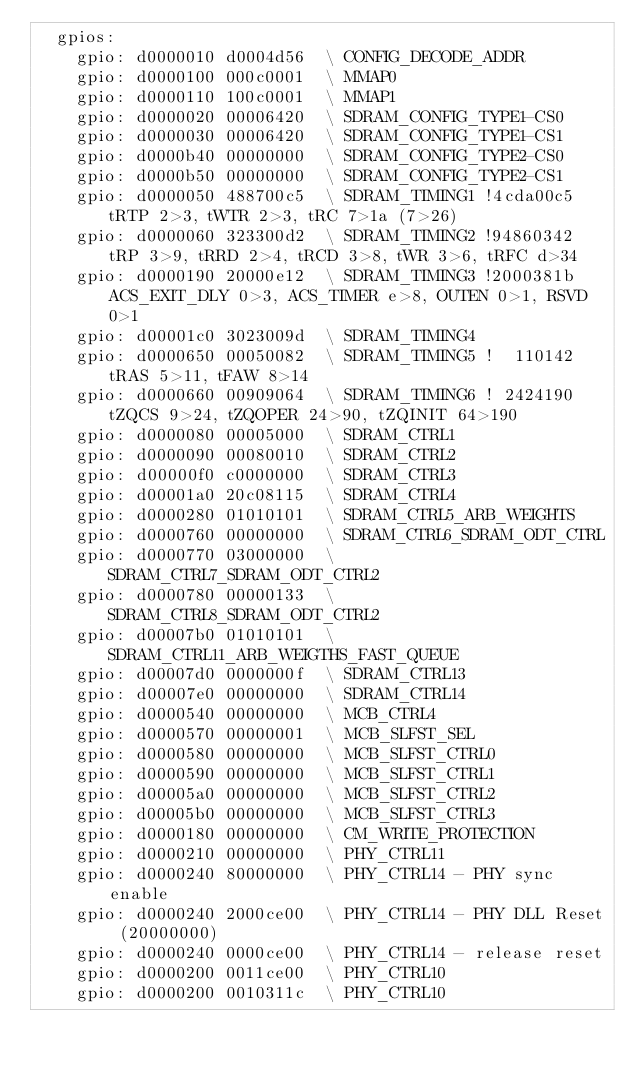Convert code to text. <code><loc_0><loc_0><loc_500><loc_500><_Forth_>  gpios:
    gpio: d0000010 d0004d56  \ CONFIG_DECODE_ADDR
    gpio: d0000100 000c0001  \ MMAP0
    gpio: d0000110 100c0001  \ MMAP1
    gpio: d0000020 00006420  \ SDRAM_CONFIG_TYPE1-CS0
    gpio: d0000030 00006420  \ SDRAM_CONFIG_TYPE1-CS1
    gpio: d0000b40 00000000  \ SDRAM_CONFIG_TYPE2-CS0
    gpio: d0000b50 00000000  \ SDRAM_CONFIG_TYPE2-CS1
    gpio: d0000050 488700c5  \ SDRAM_TIMING1 !4cda00c5 tRTP 2>3, tWTR 2>3, tRC 7>1a (7>26)
    gpio: d0000060 323300d2  \ SDRAM_TIMING2 !94860342 tRP 3>9, tRRD 2>4, tRCD 3>8, tWR 3>6, tRFC d>34
    gpio: d0000190 20000e12  \ SDRAM_TIMING3 !2000381b ACS_EXIT_DLY 0>3, ACS_TIMER e>8, OUTEN 0>1, RSVD 0>1
    gpio: d00001c0 3023009d  \ SDRAM_TIMING4
    gpio: d0000650 00050082  \ SDRAM_TIMING5 !  110142 tRAS 5>11, tFAW 8>14
    gpio: d0000660 00909064  \ SDRAM_TIMING6 ! 2424190 tZQCS 9>24, tZQOPER 24>90, tZQINIT 64>190
    gpio: d0000080 00005000  \ SDRAM_CTRL1
    gpio: d0000090 00080010  \ SDRAM_CTRL2
    gpio: d00000f0 c0000000  \ SDRAM_CTRL3
    gpio: d00001a0 20c08115  \ SDRAM_CTRL4
    gpio: d0000280 01010101  \ SDRAM_CTRL5_ARB_WEIGHTS
    gpio: d0000760 00000000  \ SDRAM_CTRL6_SDRAM_ODT_CTRL
    gpio: d0000770 03000000  \ SDRAM_CTRL7_SDRAM_ODT_CTRL2
    gpio: d0000780 00000133  \ SDRAM_CTRL8_SDRAM_ODT_CTRL2
    gpio: d00007b0 01010101  \ SDRAM_CTRL11_ARB_WEIGTHS_FAST_QUEUE
    gpio: d00007d0 0000000f  \ SDRAM_CTRL13
    gpio: d00007e0 00000000  \ SDRAM_CTRL14
    gpio: d0000540 00000000  \ MCB_CTRL4
    gpio: d0000570 00000001  \ MCB_SLFST_SEL
    gpio: d0000580 00000000  \ MCB_SLFST_CTRL0
    gpio: d0000590 00000000  \ MCB_SLFST_CTRL1
    gpio: d00005a0 00000000  \ MCB_SLFST_CTRL2
    gpio: d00005b0 00000000  \ MCB_SLFST_CTRL3
    gpio: d0000180 00000000  \ CM_WRITE_PROTECTION
    gpio: d0000210 00000000  \ PHY_CTRL11
    gpio: d0000240 80000000  \ PHY_CTRL14 - PHY sync enable
    gpio: d0000240 2000ce00  \ PHY_CTRL14 - PHY DLL Reset (20000000)
    gpio: d0000240 0000ce00  \ PHY_CTRL14 - release reset
    gpio: d0000200 0011ce00  \ PHY_CTRL10
    gpio: d0000200 0010311c  \ PHY_CTRL10</code> 